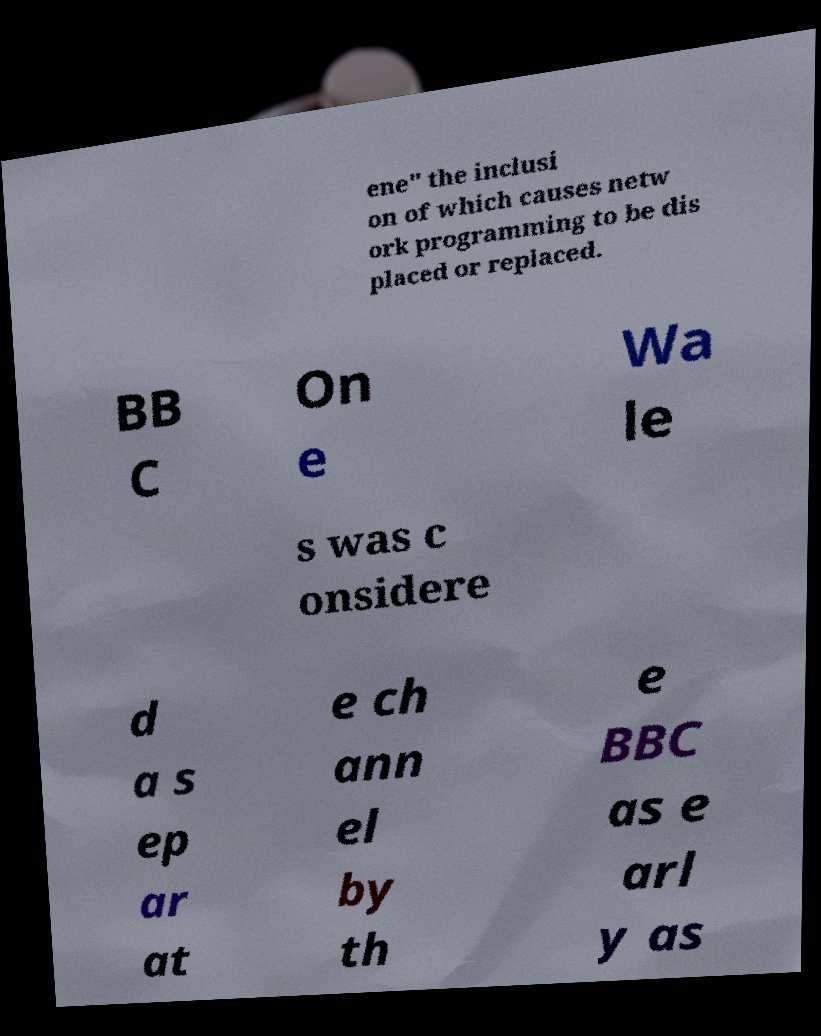Could you extract and type out the text from this image? ene" the inclusi on of which causes netw ork programming to be dis placed or replaced. BB C On e Wa le s was c onsidere d a s ep ar at e ch ann el by th e BBC as e arl y as 